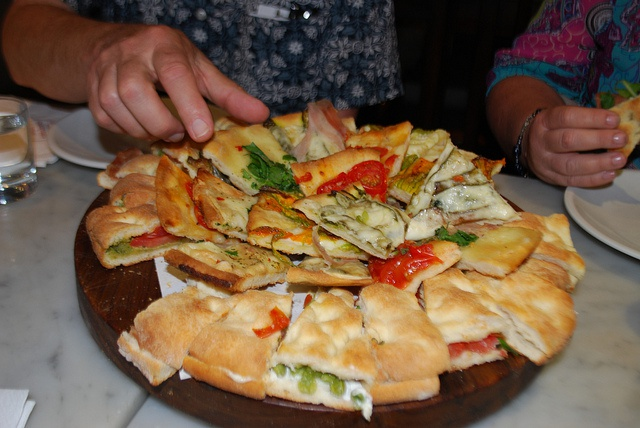Describe the objects in this image and their specific colors. I can see dining table in black, gray, tan, and brown tones, pizza in black, tan, and brown tones, people in black, maroon, brown, and gray tones, people in black, maroon, brown, and darkblue tones, and sandwich in black and tan tones in this image. 